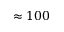<formula> <loc_0><loc_0><loc_500><loc_500>\approx 1 0 0</formula> 